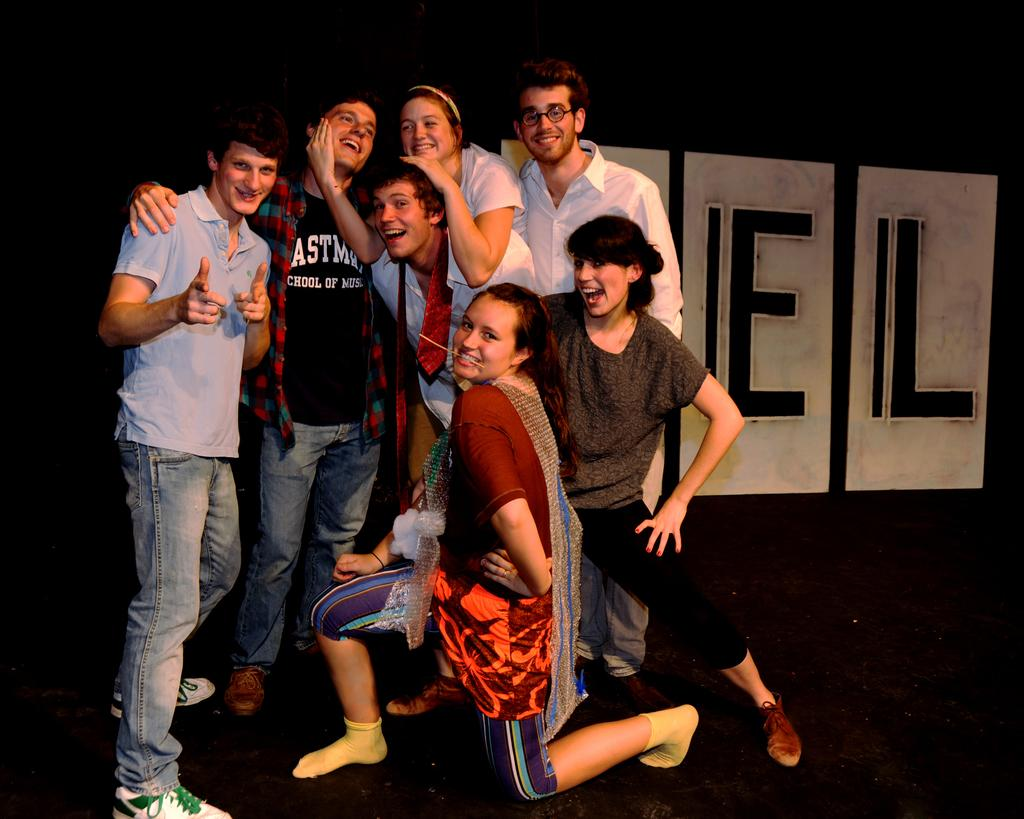What is the main subject of the image? The main subject of the image is a group of people. Where are the people located in the image? The group of people is on a path. Can you describe the position of one of the individuals in the image? There is a woman in the squat position in the image. What can be observed about the lighting in the image? The background of the image is dark. What type of health issues might the woman in the squat position be experiencing in the image? There is no information about the woman's health in the image, so it cannot be determined from the image alone. 